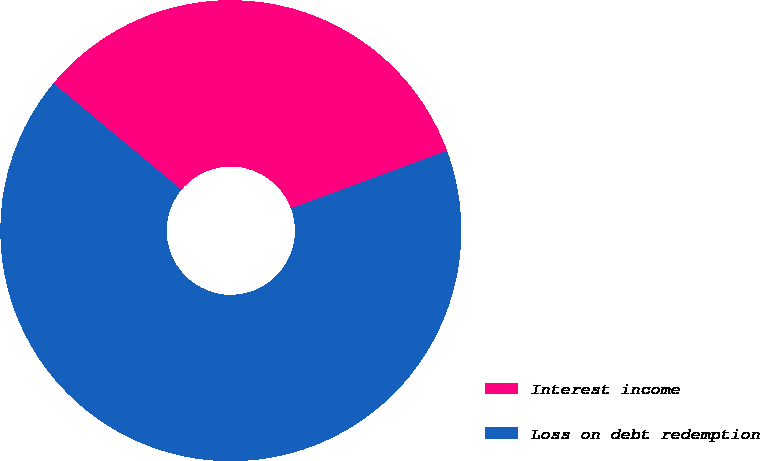<chart> <loc_0><loc_0><loc_500><loc_500><pie_chart><fcel>Interest income<fcel>Loss on debt redemption<nl><fcel>33.33%<fcel>66.67%<nl></chart> 